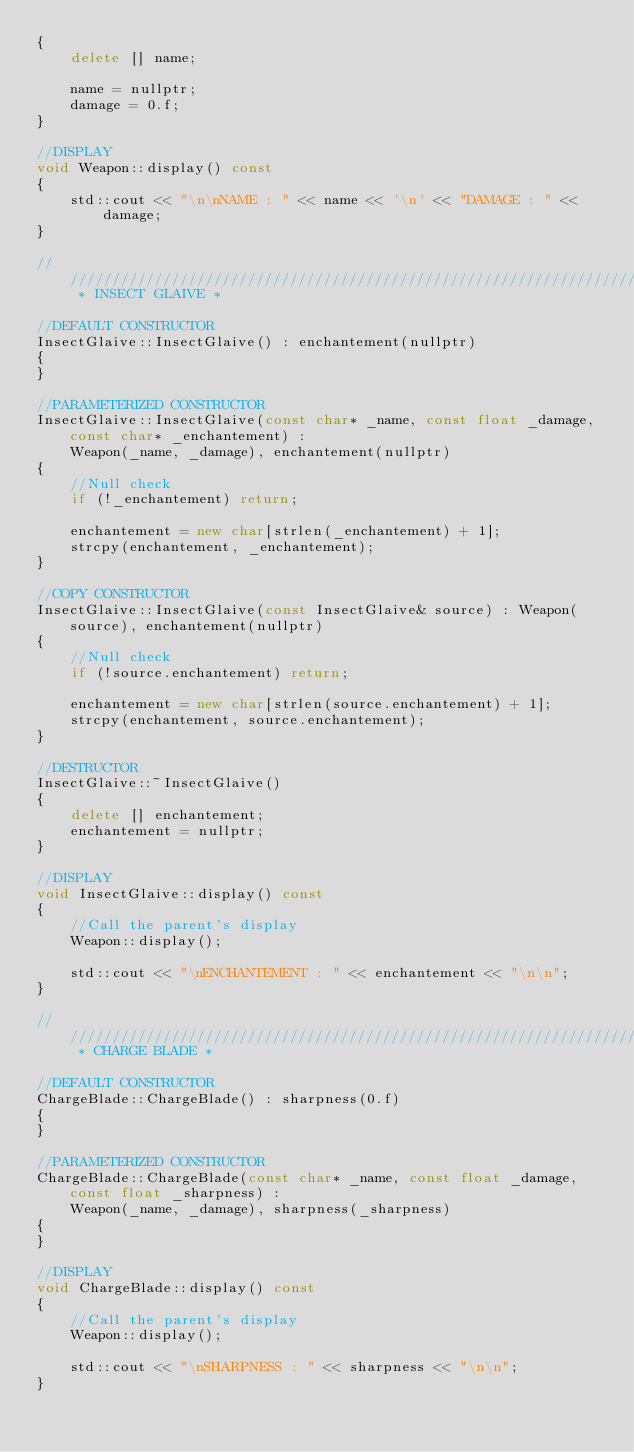<code> <loc_0><loc_0><loc_500><loc_500><_C++_>{
    delete [] name;

    name = nullptr;
    damage = 0.f;
}

//DISPLAY
void Weapon::display() const
{
    std::cout << "\n\nNAME : " << name << '\n' << "DAMAGE : " << damage;
}

//////////////////////////////////////////////////////////////////////////// * INSECT GLAIVE *

//DEFAULT CONSTRUCTOR
InsectGlaive::InsectGlaive() : enchantement(nullptr)
{
}

//PARAMETERIZED CONSTRUCTOR
InsectGlaive::InsectGlaive(const char* _name, const float _damage, const char* _enchantement) :
    Weapon(_name, _damage), enchantement(nullptr)
{
    //Null check
    if (!_enchantement) return;

    enchantement = new char[strlen(_enchantement) + 1];
    strcpy(enchantement, _enchantement);
}

//COPY CONSTRUCTOR
InsectGlaive::InsectGlaive(const InsectGlaive& source) : Weapon(source), enchantement(nullptr)
{
    //Null check
    if (!source.enchantement) return;

    enchantement = new char[strlen(source.enchantement) + 1];
    strcpy(enchantement, source.enchantement);
}

//DESTRUCTOR
InsectGlaive::~InsectGlaive()
{
    delete [] enchantement;
    enchantement = nullptr;
}

//DISPLAY
void InsectGlaive::display() const
{
    //Call the parent's display
    Weapon::display();

    std::cout << "\nENCHANTEMENT : " << enchantement << "\n\n";
}

//////////////////////////////////////////////////////////////////////////// * CHARGE BLADE *

//DEFAULT CONSTRUCTOR
ChargeBlade::ChargeBlade() : sharpness(0.f)
{
}

//PARAMETERIZED CONSTRUCTOR
ChargeBlade::ChargeBlade(const char* _name, const float _damage, const float _sharpness) :
    Weapon(_name, _damage), sharpness(_sharpness)
{
}

//DISPLAY
void ChargeBlade::display() const
{
    //Call the parent's display
    Weapon::display();

    std::cout << "\nSHARPNESS : " << sharpness << "\n\n";
}
</code> 